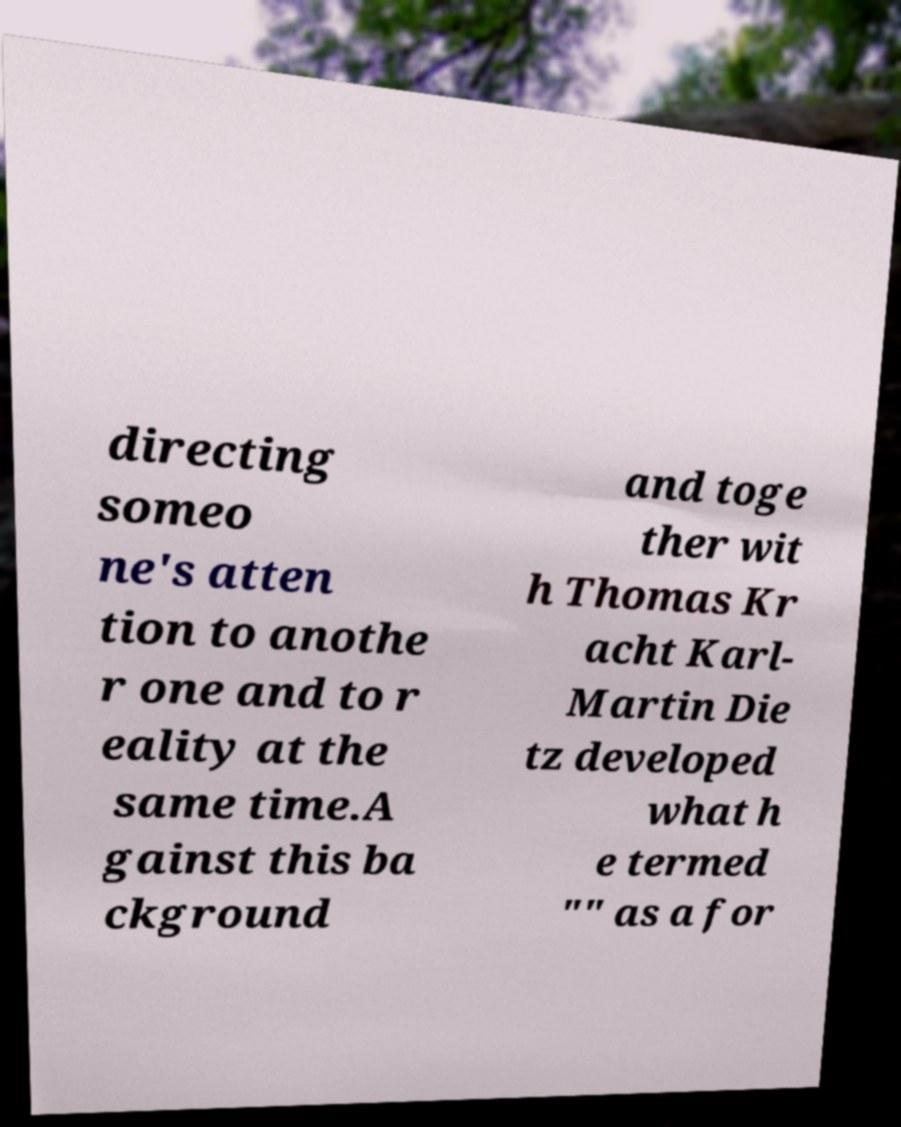Can you accurately transcribe the text from the provided image for me? directing someo ne's atten tion to anothe r one and to r eality at the same time.A gainst this ba ckground and toge ther wit h Thomas Kr acht Karl- Martin Die tz developed what h e termed "" as a for 